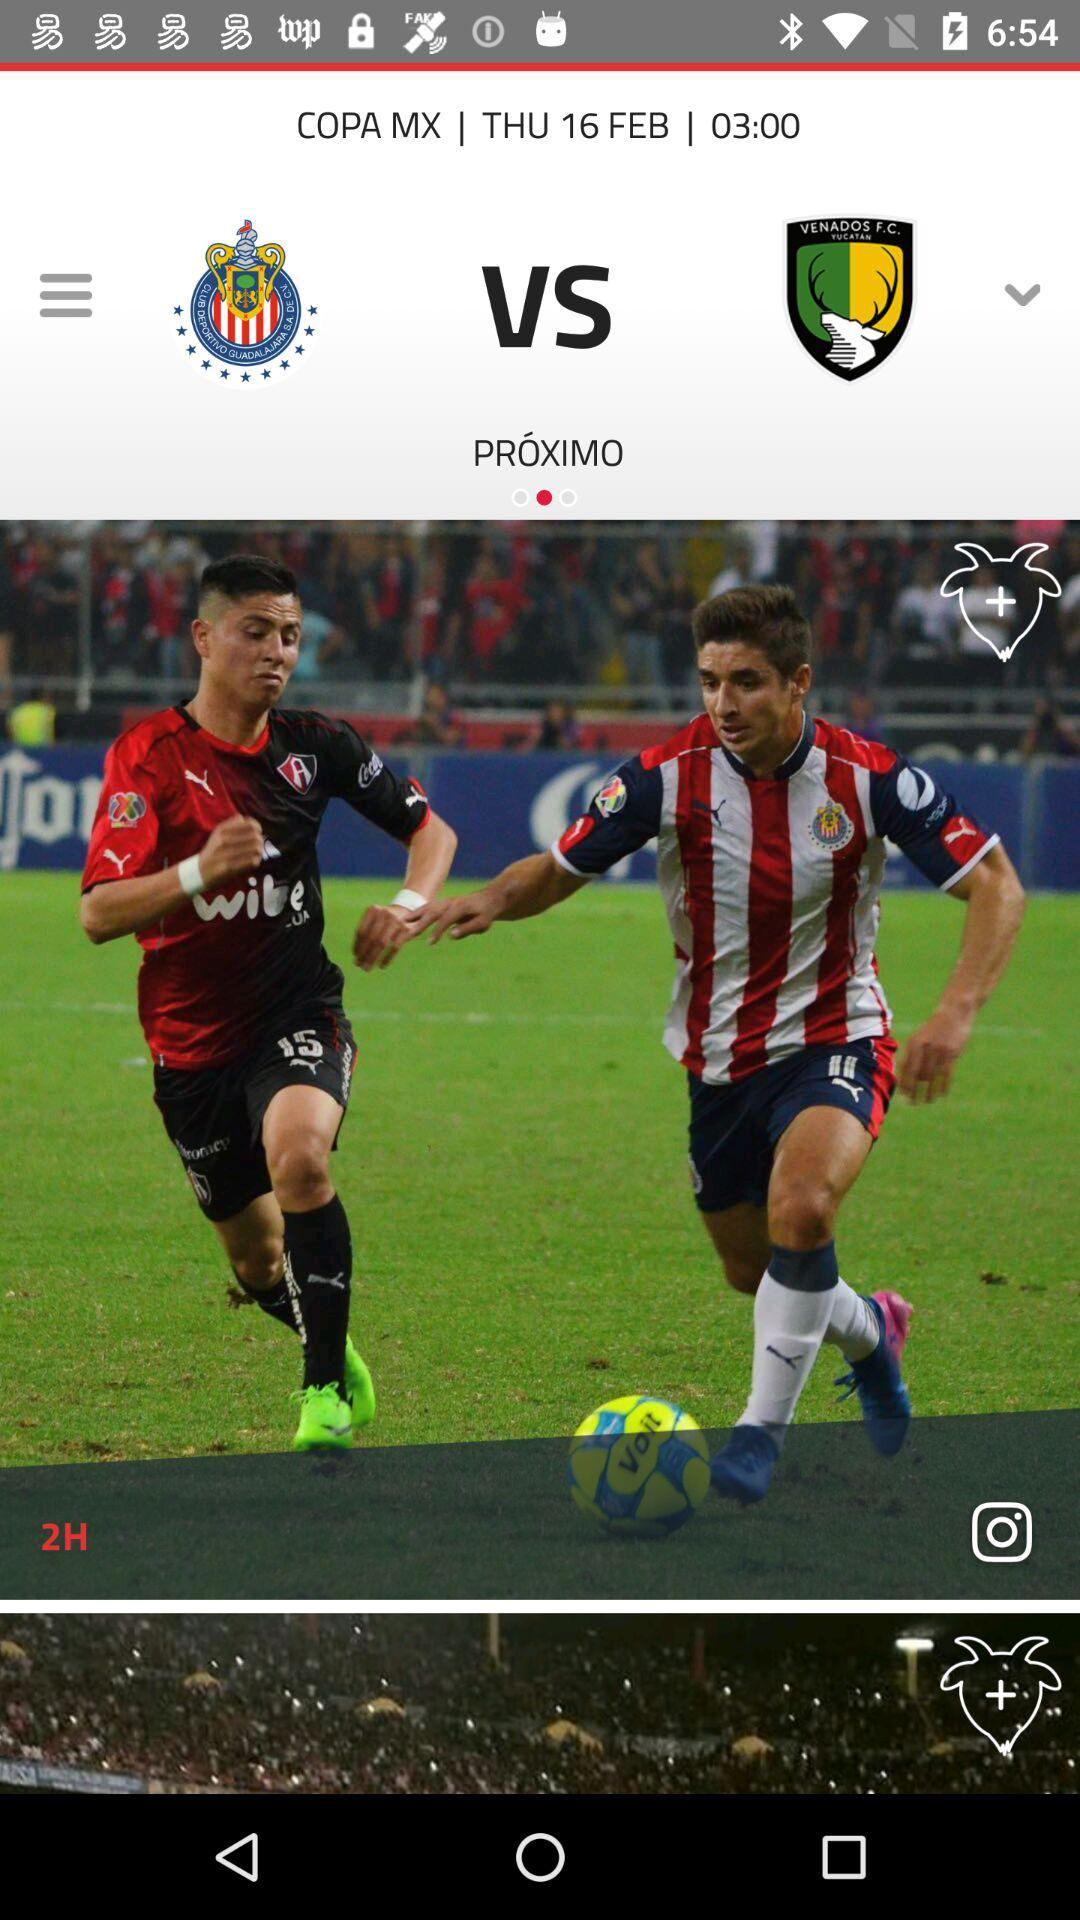How many teams are playing in the game?
Answer the question using a single word or phrase. 2 